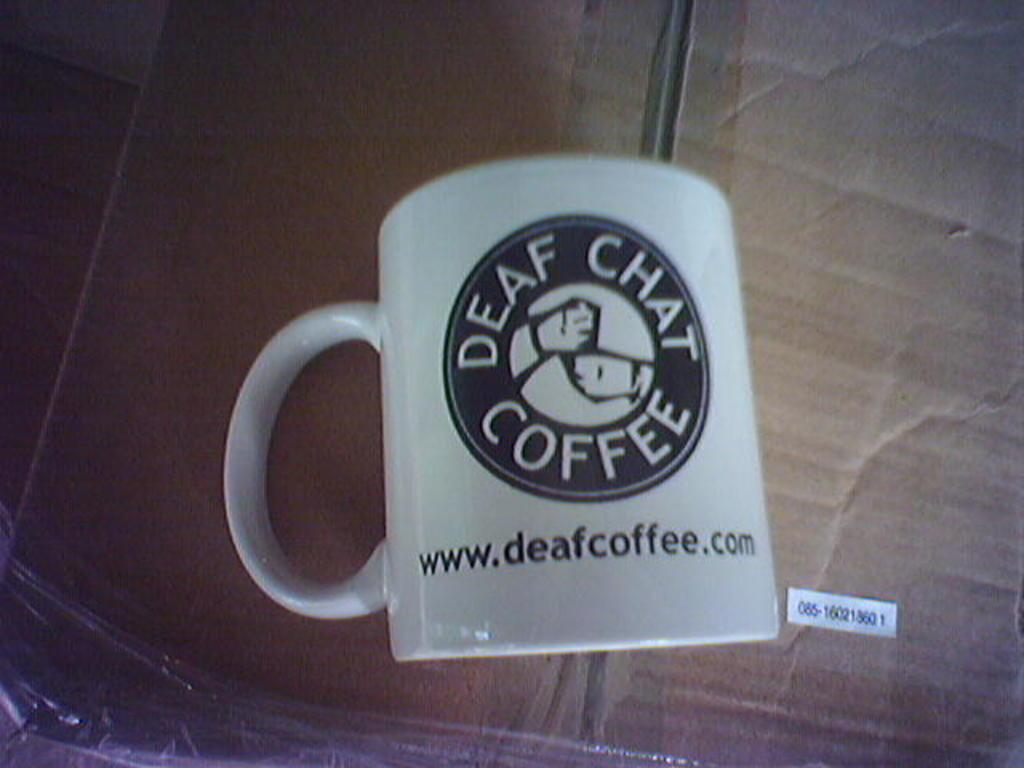<image>
Provide a brief description of the given image. A coffee mug on a table that reads Deaf Chat Coffee. 